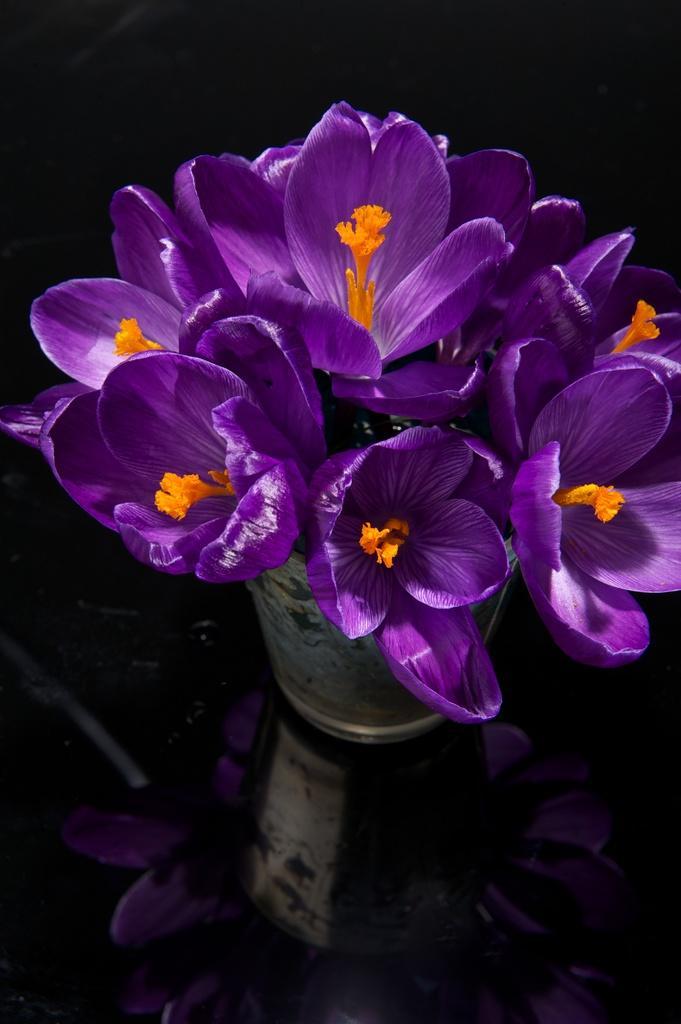Can you describe this image briefly? In the picture there are beautiful purple flowers are kept in a flower vase. 